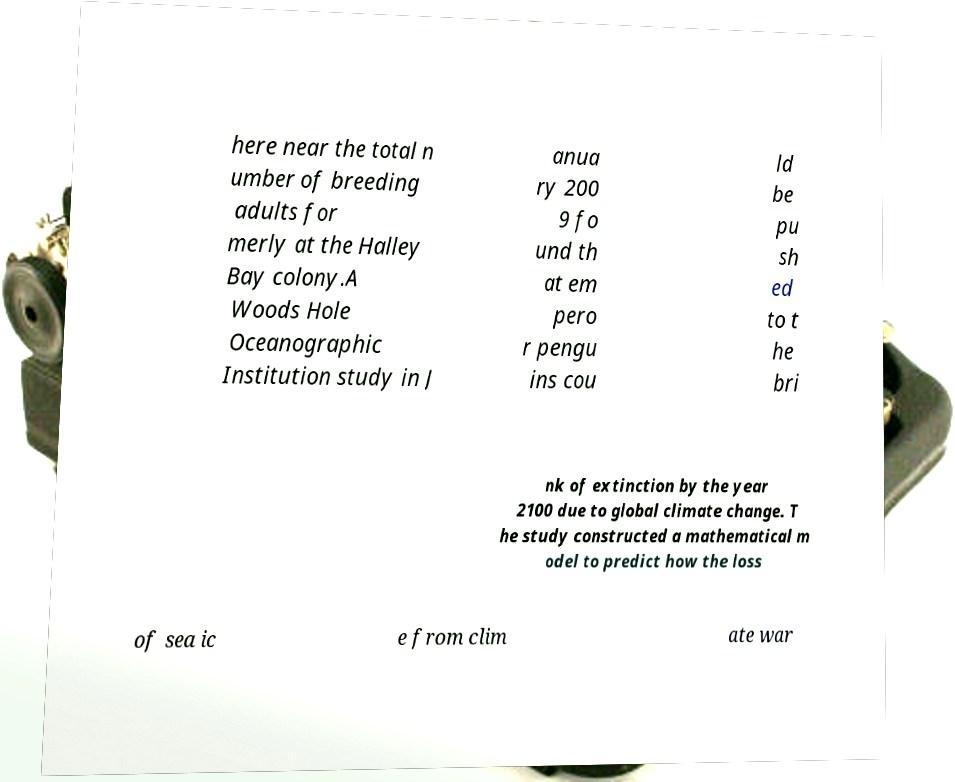Could you extract and type out the text from this image? here near the total n umber of breeding adults for merly at the Halley Bay colony.A Woods Hole Oceanographic Institution study in J anua ry 200 9 fo und th at em pero r pengu ins cou ld be pu sh ed to t he bri nk of extinction by the year 2100 due to global climate change. T he study constructed a mathematical m odel to predict how the loss of sea ic e from clim ate war 